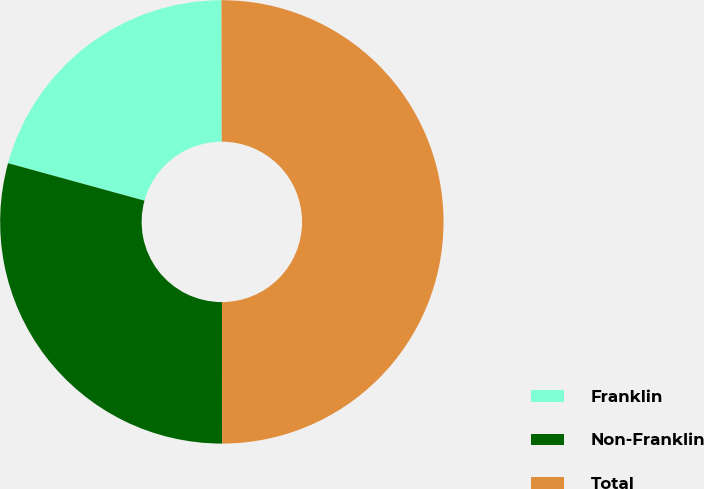Convert chart to OTSL. <chart><loc_0><loc_0><loc_500><loc_500><pie_chart><fcel>Franklin<fcel>Non-Franklin<fcel>Total<nl><fcel>20.71%<fcel>29.29%<fcel>50.0%<nl></chart> 